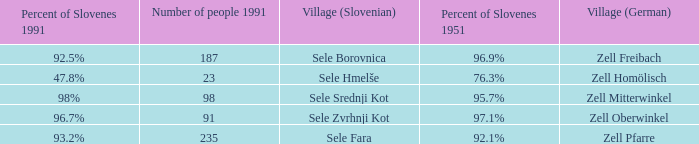Give me the minimum number of people in 1991 with 92.5% of Slovenes in 1991. 187.0. 